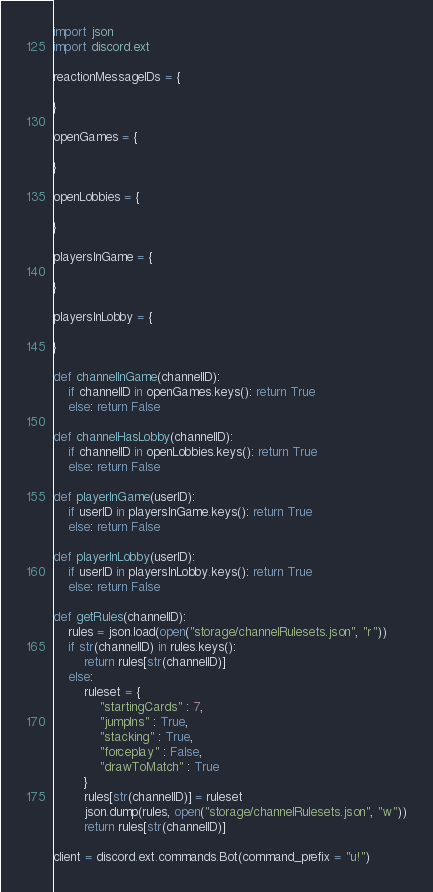Convert code to text. <code><loc_0><loc_0><loc_500><loc_500><_Python_>import json
import discord.ext

reactionMessageIDs = {
    
}

openGames = {

}

openLobbies = {

}

playersInGame = {

}

playersInLobby = {
    
}

def channelInGame(channelID):
    if channelID in openGames.keys(): return True
    else: return False
    
def channelHasLobby(channelID):
    if channelID in openLobbies.keys(): return True
    else: return False

def playerInGame(userID):
    if userID in playersInGame.keys(): return True
    else: return False

def playerInLobby(userID):
    if userID in playersInLobby.keys(): return True
    else: return False

def getRules(channelID):
    rules = json.load(open("storage/channelRulesets.json", "r"))
    if str(channelID) in rules.keys():
        return rules[str(channelID)]
    else:
        ruleset = {
            "startingCards" : 7,
            "jumpIns" : True,
            "stacking" : True,
            "forceplay" : False,
            "drawToMatch" : True
        }
        rules[str(channelID)] = ruleset
        json.dump(rules, open("storage/channelRulesets.json", "w"))
        return rules[str(channelID)]

client = discord.ext.commands.Bot(command_prefix = "u!")</code> 